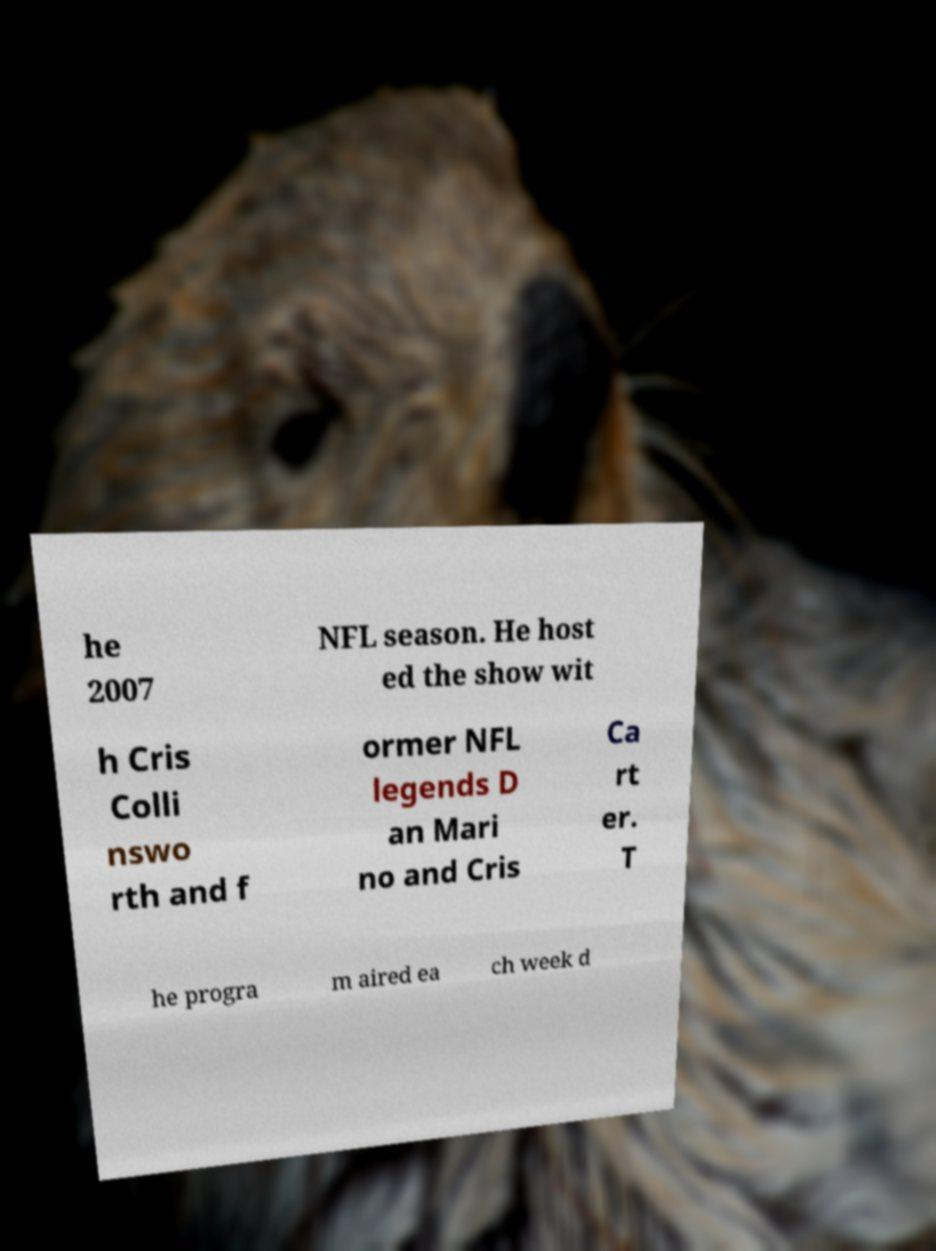There's text embedded in this image that I need extracted. Can you transcribe it verbatim? he 2007 NFL season. He host ed the show wit h Cris Colli nswo rth and f ormer NFL legends D an Mari no and Cris Ca rt er. T he progra m aired ea ch week d 